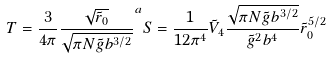<formula> <loc_0><loc_0><loc_500><loc_500>T = \frac { 3 } { 4 \pi } \frac { \sqrt { \tilde { r } _ { 0 } } } { \sqrt { \pi N \tilde { g } b ^ { 3 / 2 } } } ^ { a } S = \frac { 1 } { 1 2 \pi ^ { 4 } } \tilde { V } _ { 4 } \frac { \sqrt { \pi N \tilde { g } b ^ { 3 / 2 } } } { \tilde { g } ^ { 2 } b ^ { 4 } } \tilde { r } _ { 0 } ^ { 5 / 2 }</formula> 